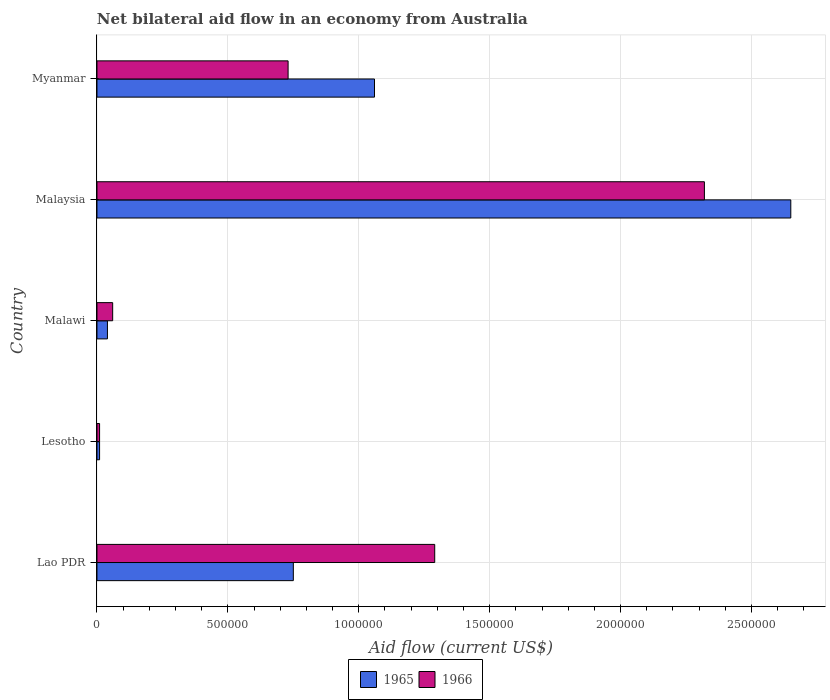How many bars are there on the 2nd tick from the bottom?
Give a very brief answer. 2. What is the label of the 4th group of bars from the top?
Your response must be concise. Lesotho. What is the net bilateral aid flow in 1965 in Malaysia?
Your answer should be very brief. 2.65e+06. Across all countries, what is the maximum net bilateral aid flow in 1965?
Offer a terse response. 2.65e+06. In which country was the net bilateral aid flow in 1965 maximum?
Your answer should be compact. Malaysia. In which country was the net bilateral aid flow in 1965 minimum?
Your response must be concise. Lesotho. What is the total net bilateral aid flow in 1966 in the graph?
Make the answer very short. 4.41e+06. What is the difference between the net bilateral aid flow in 1965 in Malawi and that in Malaysia?
Provide a short and direct response. -2.61e+06. What is the difference between the net bilateral aid flow in 1965 in Lesotho and the net bilateral aid flow in 1966 in Lao PDR?
Provide a succinct answer. -1.28e+06. What is the average net bilateral aid flow in 1965 per country?
Your answer should be very brief. 9.02e+05. What is the difference between the net bilateral aid flow in 1965 and net bilateral aid flow in 1966 in Malaysia?
Provide a short and direct response. 3.30e+05. In how many countries, is the net bilateral aid flow in 1965 greater than 600000 US$?
Make the answer very short. 3. What is the ratio of the net bilateral aid flow in 1965 in Lesotho to that in Malaysia?
Ensure brevity in your answer.  0. What is the difference between the highest and the second highest net bilateral aid flow in 1966?
Provide a short and direct response. 1.03e+06. What is the difference between the highest and the lowest net bilateral aid flow in 1965?
Offer a terse response. 2.64e+06. What does the 2nd bar from the top in Malaysia represents?
Make the answer very short. 1965. What does the 2nd bar from the bottom in Malawi represents?
Your response must be concise. 1966. How many bars are there?
Your answer should be compact. 10. How many countries are there in the graph?
Provide a succinct answer. 5. Does the graph contain any zero values?
Your answer should be compact. No. What is the title of the graph?
Your answer should be very brief. Net bilateral aid flow in an economy from Australia. What is the label or title of the X-axis?
Your answer should be very brief. Aid flow (current US$). What is the Aid flow (current US$) in 1965 in Lao PDR?
Provide a succinct answer. 7.50e+05. What is the Aid flow (current US$) in 1966 in Lao PDR?
Offer a terse response. 1.29e+06. What is the Aid flow (current US$) in 1965 in Lesotho?
Your answer should be very brief. 10000. What is the Aid flow (current US$) of 1966 in Lesotho?
Give a very brief answer. 10000. What is the Aid flow (current US$) of 1965 in Malawi?
Make the answer very short. 4.00e+04. What is the Aid flow (current US$) in 1966 in Malawi?
Offer a terse response. 6.00e+04. What is the Aid flow (current US$) of 1965 in Malaysia?
Your answer should be very brief. 2.65e+06. What is the Aid flow (current US$) in 1966 in Malaysia?
Keep it short and to the point. 2.32e+06. What is the Aid flow (current US$) in 1965 in Myanmar?
Give a very brief answer. 1.06e+06. What is the Aid flow (current US$) of 1966 in Myanmar?
Your answer should be compact. 7.30e+05. Across all countries, what is the maximum Aid flow (current US$) in 1965?
Make the answer very short. 2.65e+06. Across all countries, what is the maximum Aid flow (current US$) in 1966?
Ensure brevity in your answer.  2.32e+06. What is the total Aid flow (current US$) in 1965 in the graph?
Your answer should be compact. 4.51e+06. What is the total Aid flow (current US$) of 1966 in the graph?
Ensure brevity in your answer.  4.41e+06. What is the difference between the Aid flow (current US$) in 1965 in Lao PDR and that in Lesotho?
Give a very brief answer. 7.40e+05. What is the difference between the Aid flow (current US$) in 1966 in Lao PDR and that in Lesotho?
Your answer should be compact. 1.28e+06. What is the difference between the Aid flow (current US$) in 1965 in Lao PDR and that in Malawi?
Offer a terse response. 7.10e+05. What is the difference between the Aid flow (current US$) of 1966 in Lao PDR and that in Malawi?
Give a very brief answer. 1.23e+06. What is the difference between the Aid flow (current US$) of 1965 in Lao PDR and that in Malaysia?
Give a very brief answer. -1.90e+06. What is the difference between the Aid flow (current US$) in 1966 in Lao PDR and that in Malaysia?
Your response must be concise. -1.03e+06. What is the difference between the Aid flow (current US$) in 1965 in Lao PDR and that in Myanmar?
Provide a short and direct response. -3.10e+05. What is the difference between the Aid flow (current US$) in 1966 in Lao PDR and that in Myanmar?
Provide a short and direct response. 5.60e+05. What is the difference between the Aid flow (current US$) of 1965 in Lesotho and that in Malawi?
Provide a short and direct response. -3.00e+04. What is the difference between the Aid flow (current US$) in 1965 in Lesotho and that in Malaysia?
Your answer should be very brief. -2.64e+06. What is the difference between the Aid flow (current US$) of 1966 in Lesotho and that in Malaysia?
Your answer should be very brief. -2.31e+06. What is the difference between the Aid flow (current US$) of 1965 in Lesotho and that in Myanmar?
Your answer should be very brief. -1.05e+06. What is the difference between the Aid flow (current US$) of 1966 in Lesotho and that in Myanmar?
Provide a short and direct response. -7.20e+05. What is the difference between the Aid flow (current US$) in 1965 in Malawi and that in Malaysia?
Keep it short and to the point. -2.61e+06. What is the difference between the Aid flow (current US$) in 1966 in Malawi and that in Malaysia?
Provide a succinct answer. -2.26e+06. What is the difference between the Aid flow (current US$) in 1965 in Malawi and that in Myanmar?
Ensure brevity in your answer.  -1.02e+06. What is the difference between the Aid flow (current US$) of 1966 in Malawi and that in Myanmar?
Ensure brevity in your answer.  -6.70e+05. What is the difference between the Aid flow (current US$) in 1965 in Malaysia and that in Myanmar?
Your answer should be compact. 1.59e+06. What is the difference between the Aid flow (current US$) in 1966 in Malaysia and that in Myanmar?
Provide a succinct answer. 1.59e+06. What is the difference between the Aid flow (current US$) in 1965 in Lao PDR and the Aid flow (current US$) in 1966 in Lesotho?
Make the answer very short. 7.40e+05. What is the difference between the Aid flow (current US$) in 1965 in Lao PDR and the Aid flow (current US$) in 1966 in Malawi?
Provide a short and direct response. 6.90e+05. What is the difference between the Aid flow (current US$) in 1965 in Lao PDR and the Aid flow (current US$) in 1966 in Malaysia?
Provide a succinct answer. -1.57e+06. What is the difference between the Aid flow (current US$) of 1965 in Lao PDR and the Aid flow (current US$) of 1966 in Myanmar?
Provide a short and direct response. 2.00e+04. What is the difference between the Aid flow (current US$) of 1965 in Lesotho and the Aid flow (current US$) of 1966 in Malawi?
Make the answer very short. -5.00e+04. What is the difference between the Aid flow (current US$) of 1965 in Lesotho and the Aid flow (current US$) of 1966 in Malaysia?
Your answer should be very brief. -2.31e+06. What is the difference between the Aid flow (current US$) of 1965 in Lesotho and the Aid flow (current US$) of 1966 in Myanmar?
Your response must be concise. -7.20e+05. What is the difference between the Aid flow (current US$) of 1965 in Malawi and the Aid flow (current US$) of 1966 in Malaysia?
Make the answer very short. -2.28e+06. What is the difference between the Aid flow (current US$) in 1965 in Malawi and the Aid flow (current US$) in 1966 in Myanmar?
Keep it short and to the point. -6.90e+05. What is the difference between the Aid flow (current US$) in 1965 in Malaysia and the Aid flow (current US$) in 1966 in Myanmar?
Make the answer very short. 1.92e+06. What is the average Aid flow (current US$) of 1965 per country?
Keep it short and to the point. 9.02e+05. What is the average Aid flow (current US$) of 1966 per country?
Provide a short and direct response. 8.82e+05. What is the difference between the Aid flow (current US$) of 1965 and Aid flow (current US$) of 1966 in Lao PDR?
Ensure brevity in your answer.  -5.40e+05. What is the difference between the Aid flow (current US$) in 1965 and Aid flow (current US$) in 1966 in Lesotho?
Your answer should be compact. 0. What is the difference between the Aid flow (current US$) of 1965 and Aid flow (current US$) of 1966 in Malawi?
Ensure brevity in your answer.  -2.00e+04. What is the ratio of the Aid flow (current US$) in 1966 in Lao PDR to that in Lesotho?
Your answer should be compact. 129. What is the ratio of the Aid flow (current US$) in 1965 in Lao PDR to that in Malawi?
Offer a very short reply. 18.75. What is the ratio of the Aid flow (current US$) of 1966 in Lao PDR to that in Malawi?
Your response must be concise. 21.5. What is the ratio of the Aid flow (current US$) of 1965 in Lao PDR to that in Malaysia?
Provide a short and direct response. 0.28. What is the ratio of the Aid flow (current US$) in 1966 in Lao PDR to that in Malaysia?
Your answer should be compact. 0.56. What is the ratio of the Aid flow (current US$) in 1965 in Lao PDR to that in Myanmar?
Offer a terse response. 0.71. What is the ratio of the Aid flow (current US$) in 1966 in Lao PDR to that in Myanmar?
Make the answer very short. 1.77. What is the ratio of the Aid flow (current US$) in 1965 in Lesotho to that in Malawi?
Ensure brevity in your answer.  0.25. What is the ratio of the Aid flow (current US$) in 1966 in Lesotho to that in Malawi?
Your response must be concise. 0.17. What is the ratio of the Aid flow (current US$) of 1965 in Lesotho to that in Malaysia?
Your answer should be very brief. 0. What is the ratio of the Aid flow (current US$) of 1966 in Lesotho to that in Malaysia?
Make the answer very short. 0. What is the ratio of the Aid flow (current US$) of 1965 in Lesotho to that in Myanmar?
Ensure brevity in your answer.  0.01. What is the ratio of the Aid flow (current US$) in 1966 in Lesotho to that in Myanmar?
Your answer should be very brief. 0.01. What is the ratio of the Aid flow (current US$) of 1965 in Malawi to that in Malaysia?
Offer a terse response. 0.02. What is the ratio of the Aid flow (current US$) of 1966 in Malawi to that in Malaysia?
Your answer should be compact. 0.03. What is the ratio of the Aid flow (current US$) in 1965 in Malawi to that in Myanmar?
Ensure brevity in your answer.  0.04. What is the ratio of the Aid flow (current US$) of 1966 in Malawi to that in Myanmar?
Your response must be concise. 0.08. What is the ratio of the Aid flow (current US$) of 1965 in Malaysia to that in Myanmar?
Provide a short and direct response. 2.5. What is the ratio of the Aid flow (current US$) of 1966 in Malaysia to that in Myanmar?
Your response must be concise. 3.18. What is the difference between the highest and the second highest Aid flow (current US$) in 1965?
Offer a terse response. 1.59e+06. What is the difference between the highest and the second highest Aid flow (current US$) of 1966?
Provide a short and direct response. 1.03e+06. What is the difference between the highest and the lowest Aid flow (current US$) of 1965?
Your response must be concise. 2.64e+06. What is the difference between the highest and the lowest Aid flow (current US$) in 1966?
Keep it short and to the point. 2.31e+06. 